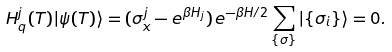Convert formula to latex. <formula><loc_0><loc_0><loc_500><loc_500>H _ { q } ^ { j } ( T ) | \psi ( T ) \rangle = ( \sigma _ { x } ^ { j } - e ^ { \beta H _ { j } } ) \, e ^ { - \beta H / 2 } \sum _ { \{ \sigma \} } | \{ \sigma _ { i } \} \rangle = 0 .</formula> 